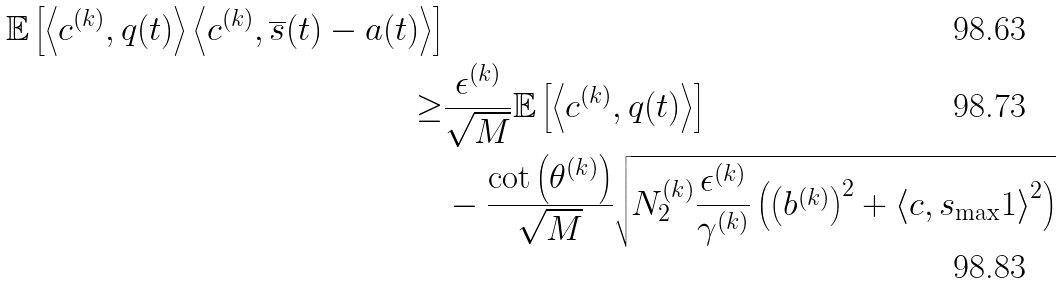<formula> <loc_0><loc_0><loc_500><loc_500>{ \mathbb { E } \left [ \left \langle c ^ { ( k ) } , q ( t ) \right \rangle \left \langle c ^ { ( k ) } , \overline { s } ( t ) - a ( t ) \right \rangle \right ] } \\ \geq & \frac { \epsilon ^ { ( k ) } } { \sqrt { M } } \mathbb { E } \left [ \left \langle c ^ { ( k ) } , q ( t ) \right \rangle \right ] \\ & - \frac { \cot \left ( \theta ^ { ( k ) } \right ) } { \sqrt { M } } \sqrt { N _ { 2 } ^ { ( k ) } \frac { \epsilon ^ { ( k ) } } { \gamma ^ { ( k ) } } \left ( \left ( b ^ { ( k ) } \right ) ^ { 2 } + \left \langle c , s _ { \max } 1 \right \rangle ^ { 2 } \right ) }</formula> 